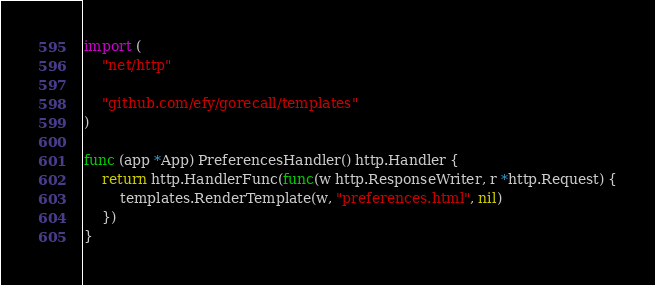<code> <loc_0><loc_0><loc_500><loc_500><_Go_>
import (
	"net/http"

	"github.com/efy/gorecall/templates"
)

func (app *App) PreferencesHandler() http.Handler {
	return http.HandlerFunc(func(w http.ResponseWriter, r *http.Request) {
		templates.RenderTemplate(w, "preferences.html", nil)
	})
}
</code> 